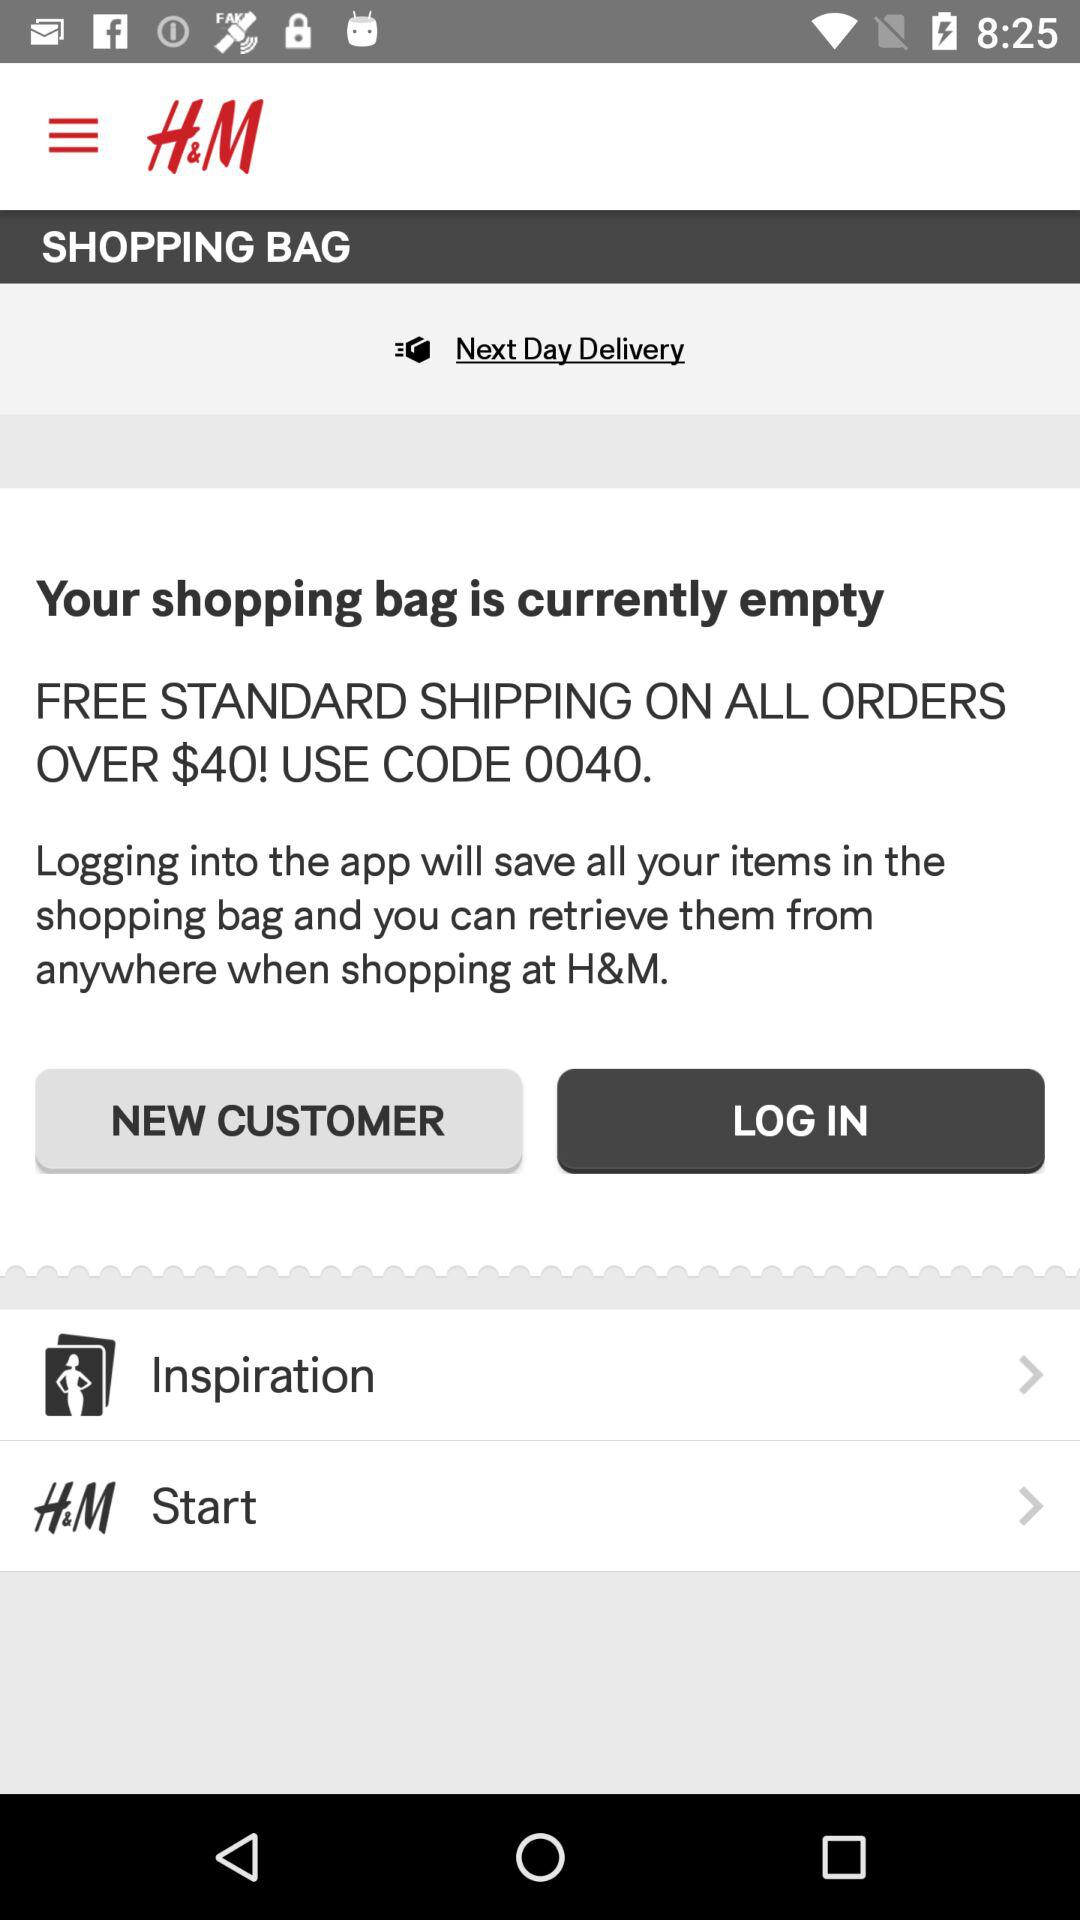What is the user name?
When the provided information is insufficient, respond with <no answer>. <no answer> 